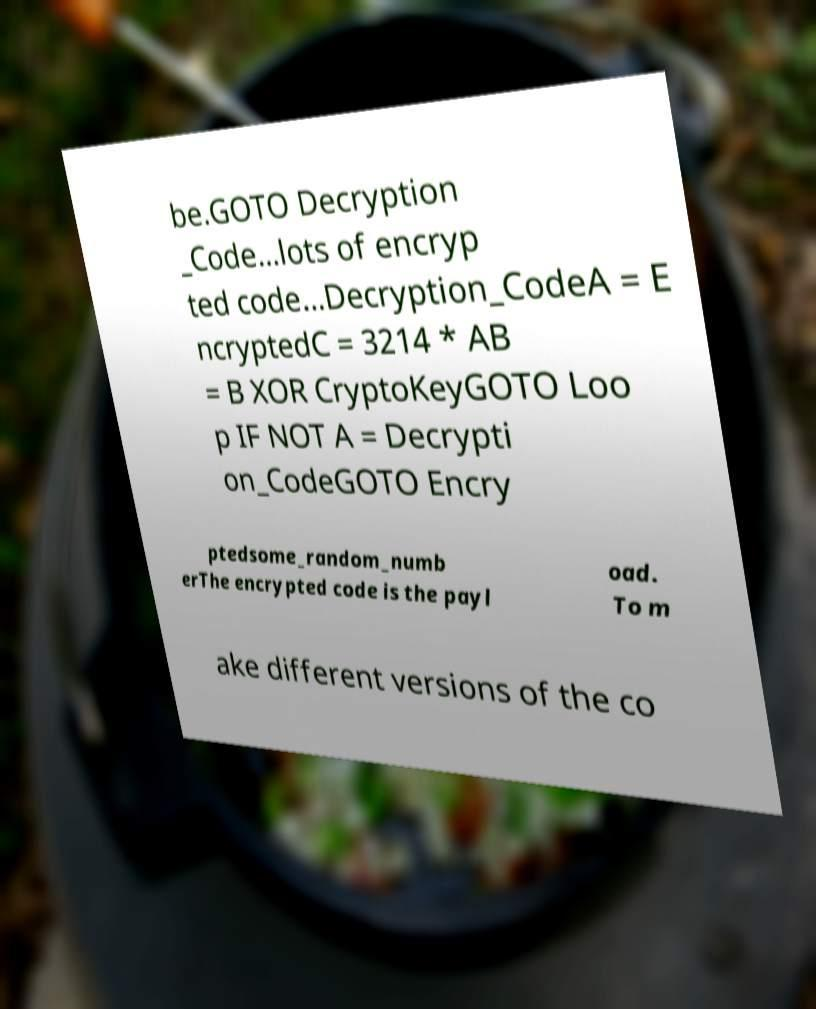What messages or text are displayed in this image? I need them in a readable, typed format. be.GOTO Decryption _Code...lots of encryp ted code...Decryption_CodeA = E ncryptedC = 3214 * AB = B XOR CryptoKeyGOTO Loo p IF NOT A = Decrypti on_CodeGOTO Encry ptedsome_random_numb erThe encrypted code is the payl oad. To m ake different versions of the co 